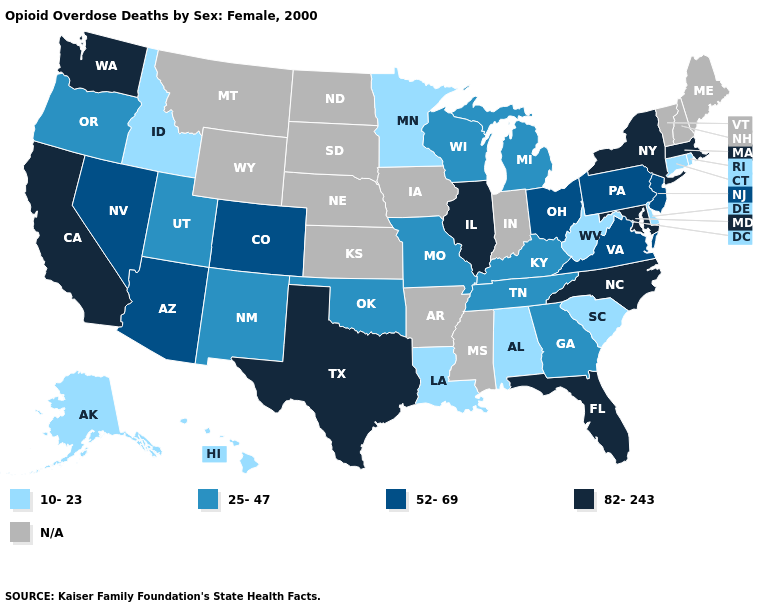Does the map have missing data?
Keep it brief. Yes. Among the states that border Ohio , does Pennsylvania have the lowest value?
Short answer required. No. How many symbols are there in the legend?
Concise answer only. 5. Among the states that border Colorado , does Arizona have the lowest value?
Be succinct. No. What is the value of New York?
Answer briefly. 82-243. Name the states that have a value in the range N/A?
Keep it brief. Arkansas, Indiana, Iowa, Kansas, Maine, Mississippi, Montana, Nebraska, New Hampshire, North Dakota, South Dakota, Vermont, Wyoming. What is the value of Wyoming?
Short answer required. N/A. Name the states that have a value in the range 10-23?
Write a very short answer. Alabama, Alaska, Connecticut, Delaware, Hawaii, Idaho, Louisiana, Minnesota, Rhode Island, South Carolina, West Virginia. Is the legend a continuous bar?
Keep it brief. No. What is the highest value in the USA?
Be succinct. 82-243. Name the states that have a value in the range 25-47?
Give a very brief answer. Georgia, Kentucky, Michigan, Missouri, New Mexico, Oklahoma, Oregon, Tennessee, Utah, Wisconsin. What is the highest value in the USA?
Concise answer only. 82-243. What is the lowest value in states that border Wisconsin?
Concise answer only. 10-23. What is the value of Alabama?
Quick response, please. 10-23. What is the value of Ohio?
Short answer required. 52-69. 